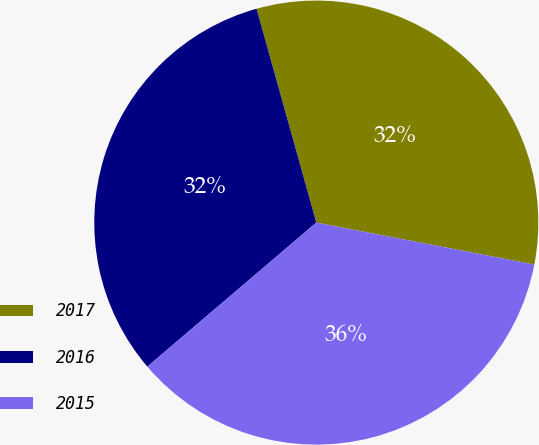Convert chart to OTSL. <chart><loc_0><loc_0><loc_500><loc_500><pie_chart><fcel>2017<fcel>2016<fcel>2015<nl><fcel>32.36%<fcel>31.9%<fcel>35.74%<nl></chart> 